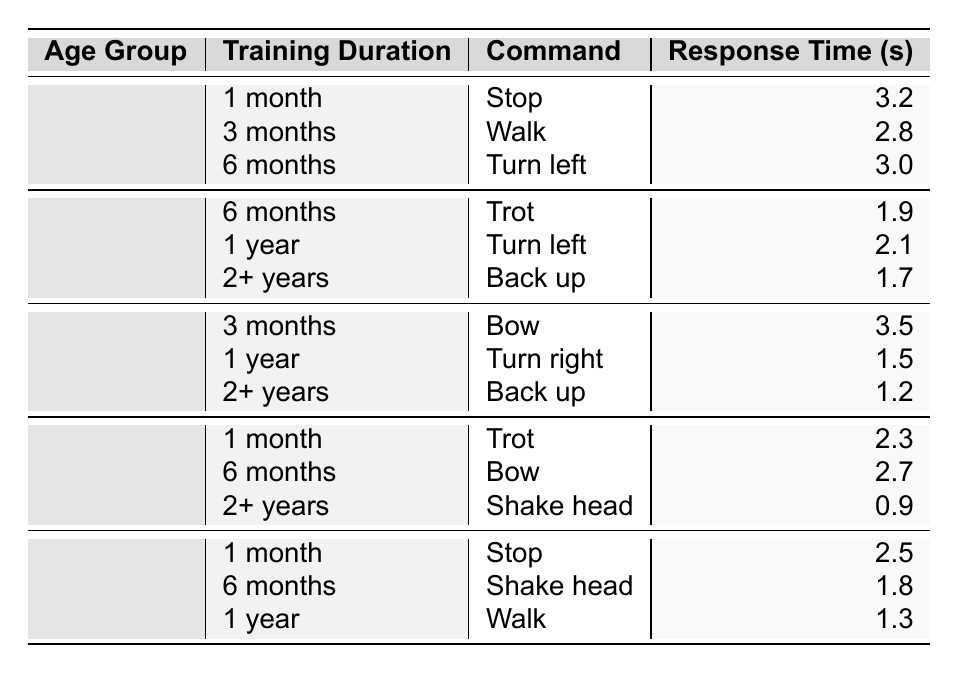What is the response time for the command "Trot" in the age group 3-5 years with 6 months of training? Looking at the table, the response time for the command "Trot" in the age group 3-5 years with 6 months of training is 1.9 seconds.
Answer: 1.9 seconds Which age group has the longest response time for the command "Bow"? The longest response time for "Bow" is seen in the age group 6-10 years, where the response time is 3.5 seconds.
Answer: 6-10 years What is the average response time for the command "Shake head" across all age groups? The response times for "Shake head" are 0.9 seconds (11-15 years with 2+ years training) and 1.8 seconds (16+ years with 6 months training). To find the average, sum these response times: 0.9 + 1.8 = 2.7, then divide by 2 to get 2.7/2 = 1.35 seconds.
Answer: 1.35 seconds Is it true that the response time for "Back up" is faster in the age group 6-10 years than in the age group 3-5 years? Yes, in the 6-10 years age group with training durations of 2+ years, the response time for "Back up" is 1.2 seconds, which is faster than 1.7 seconds for the same command in the 3-5 years age group with 2+ years of training.
Answer: Yes Which command has the fastest response time among all training durations for age group 11-15 years? Reviewing the table, "Shake head" with a training duration of 2+ years has the fastest response time at 0.9 seconds compared to other commands.
Answer: Shake head What is the difference in response time for the command "Stop" between the age groups 0-2 years and 16+ years? The response time for "Stop" in the 0-2 years age group is 3.2 seconds, and in the 16+ years age group, it is 2.5 seconds. The difference is calculated as 3.2 - 2.5 = 0.7 seconds.
Answer: 0.7 seconds For the age group 6-10 years, which training duration results in the fastest response time for the command "Turn right"? In the age group 6-10 years, "Turn right" has a response time of 1.5 seconds with 1 year of training, which is the only data point for this command in this age group.
Answer: 1.5 seconds Which command showed the most improvement in response time when comparing the longest and shortest response times across training durations? By analyzing the response times, "Shake head" decreased from 1.8 seconds (16+ years with 6 months training) to 0.9 seconds (11-15 years with 2+ years training), showing an improvement of 0.9 seconds.
Answer: 0.9 seconds 